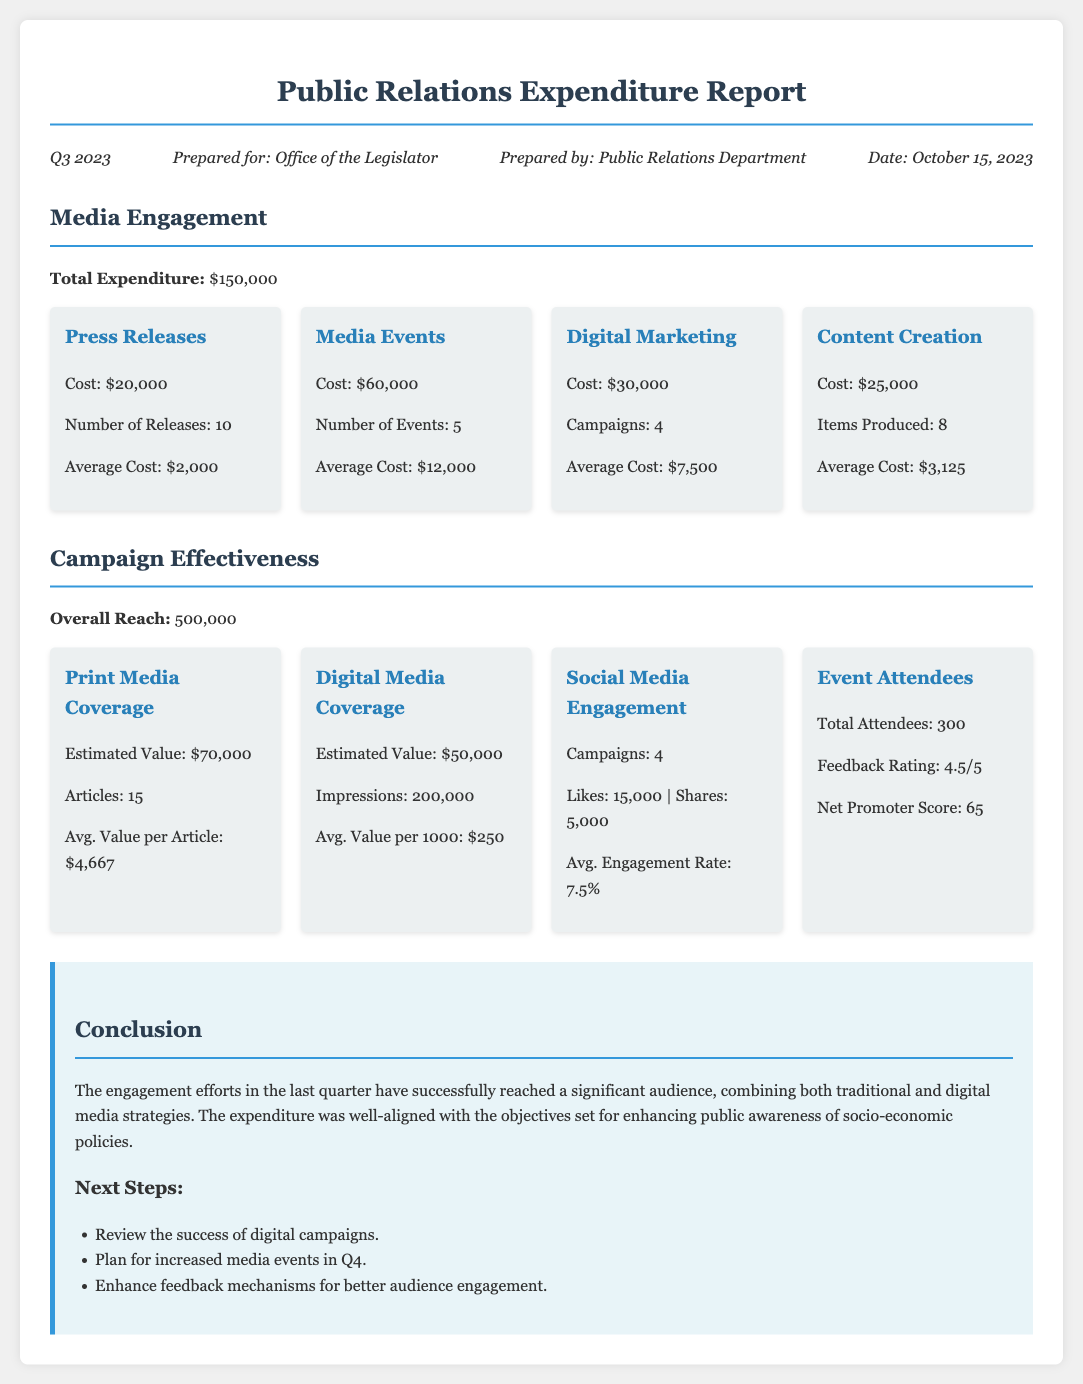What was the total expenditure on media engagement? The total expenditure is stated in the document as $150,000.
Answer: $150,000 How many press releases were issued? The document specifies that there were 10 press releases issued.
Answer: 10 What was the cost of media events? The cost of media events is detailed in the document as $60,000.
Answer: $60,000 What was the average value per article in print media coverage? The average value per article is calculated as $4,667, as stated in the document.
Answer: $4,667 What is the estimated value of digital media coverage? The estimated value of digital media coverage is listed as $50,000 in the report.
Answer: $50,000 How many total attendees were at the media events? The document notes that there were 300 total attendees at the events.
Answer: 300 What was the feedback rating from event attendees? The document indicates that the feedback rating was 4.5 out of 5.
Answer: 4.5/5 What is the average engagement rate for social media? The document records the average engagement rate as 7.5%.
Answer: 7.5% What is the next step proposed regarding digital campaigns? The document suggests reviewing the success of digital campaigns as a next step.
Answer: Review digital campaigns 